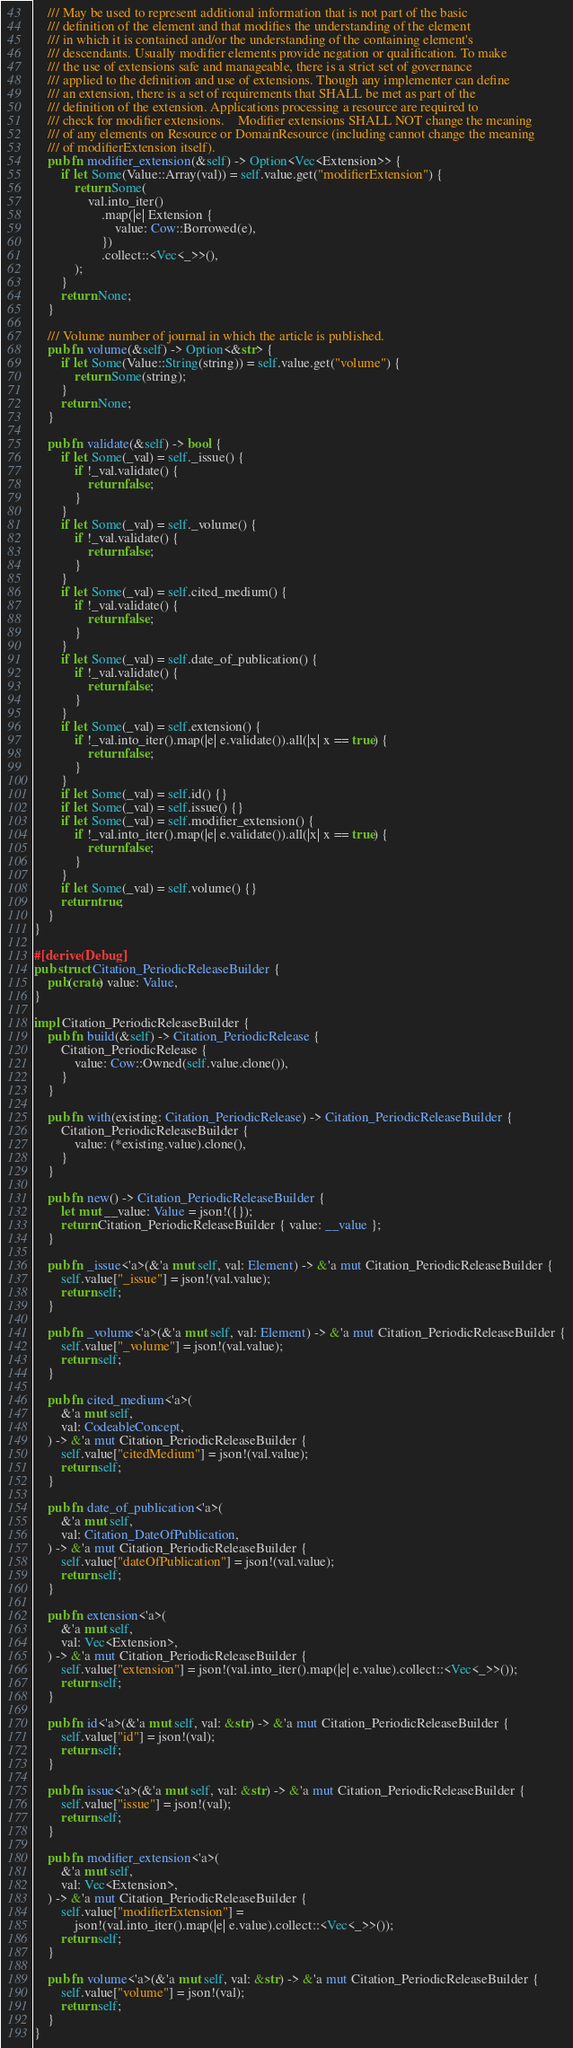Convert code to text. <code><loc_0><loc_0><loc_500><loc_500><_Rust_>
    /// May be used to represent additional information that is not part of the basic
    /// definition of the element and that modifies the understanding of the element
    /// in which it is contained and/or the understanding of the containing element's
    /// descendants. Usually modifier elements provide negation or qualification. To make
    /// the use of extensions safe and manageable, there is a strict set of governance
    /// applied to the definition and use of extensions. Though any implementer can define
    /// an extension, there is a set of requirements that SHALL be met as part of the
    /// definition of the extension. Applications processing a resource are required to
    /// check for modifier extensions.    Modifier extensions SHALL NOT change the meaning
    /// of any elements on Resource or DomainResource (including cannot change the meaning
    /// of modifierExtension itself).
    pub fn modifier_extension(&self) -> Option<Vec<Extension>> {
        if let Some(Value::Array(val)) = self.value.get("modifierExtension") {
            return Some(
                val.into_iter()
                    .map(|e| Extension {
                        value: Cow::Borrowed(e),
                    })
                    .collect::<Vec<_>>(),
            );
        }
        return None;
    }

    /// Volume number of journal in which the article is published.
    pub fn volume(&self) -> Option<&str> {
        if let Some(Value::String(string)) = self.value.get("volume") {
            return Some(string);
        }
        return None;
    }

    pub fn validate(&self) -> bool {
        if let Some(_val) = self._issue() {
            if !_val.validate() {
                return false;
            }
        }
        if let Some(_val) = self._volume() {
            if !_val.validate() {
                return false;
            }
        }
        if let Some(_val) = self.cited_medium() {
            if !_val.validate() {
                return false;
            }
        }
        if let Some(_val) = self.date_of_publication() {
            if !_val.validate() {
                return false;
            }
        }
        if let Some(_val) = self.extension() {
            if !_val.into_iter().map(|e| e.validate()).all(|x| x == true) {
                return false;
            }
        }
        if let Some(_val) = self.id() {}
        if let Some(_val) = self.issue() {}
        if let Some(_val) = self.modifier_extension() {
            if !_val.into_iter().map(|e| e.validate()).all(|x| x == true) {
                return false;
            }
        }
        if let Some(_val) = self.volume() {}
        return true;
    }
}

#[derive(Debug)]
pub struct Citation_PeriodicReleaseBuilder {
    pub(crate) value: Value,
}

impl Citation_PeriodicReleaseBuilder {
    pub fn build(&self) -> Citation_PeriodicRelease {
        Citation_PeriodicRelease {
            value: Cow::Owned(self.value.clone()),
        }
    }

    pub fn with(existing: Citation_PeriodicRelease) -> Citation_PeriodicReleaseBuilder {
        Citation_PeriodicReleaseBuilder {
            value: (*existing.value).clone(),
        }
    }

    pub fn new() -> Citation_PeriodicReleaseBuilder {
        let mut __value: Value = json!({});
        return Citation_PeriodicReleaseBuilder { value: __value };
    }

    pub fn _issue<'a>(&'a mut self, val: Element) -> &'a mut Citation_PeriodicReleaseBuilder {
        self.value["_issue"] = json!(val.value);
        return self;
    }

    pub fn _volume<'a>(&'a mut self, val: Element) -> &'a mut Citation_PeriodicReleaseBuilder {
        self.value["_volume"] = json!(val.value);
        return self;
    }

    pub fn cited_medium<'a>(
        &'a mut self,
        val: CodeableConcept,
    ) -> &'a mut Citation_PeriodicReleaseBuilder {
        self.value["citedMedium"] = json!(val.value);
        return self;
    }

    pub fn date_of_publication<'a>(
        &'a mut self,
        val: Citation_DateOfPublication,
    ) -> &'a mut Citation_PeriodicReleaseBuilder {
        self.value["dateOfPublication"] = json!(val.value);
        return self;
    }

    pub fn extension<'a>(
        &'a mut self,
        val: Vec<Extension>,
    ) -> &'a mut Citation_PeriodicReleaseBuilder {
        self.value["extension"] = json!(val.into_iter().map(|e| e.value).collect::<Vec<_>>());
        return self;
    }

    pub fn id<'a>(&'a mut self, val: &str) -> &'a mut Citation_PeriodicReleaseBuilder {
        self.value["id"] = json!(val);
        return self;
    }

    pub fn issue<'a>(&'a mut self, val: &str) -> &'a mut Citation_PeriodicReleaseBuilder {
        self.value["issue"] = json!(val);
        return self;
    }

    pub fn modifier_extension<'a>(
        &'a mut self,
        val: Vec<Extension>,
    ) -> &'a mut Citation_PeriodicReleaseBuilder {
        self.value["modifierExtension"] =
            json!(val.into_iter().map(|e| e.value).collect::<Vec<_>>());
        return self;
    }

    pub fn volume<'a>(&'a mut self, val: &str) -> &'a mut Citation_PeriodicReleaseBuilder {
        self.value["volume"] = json!(val);
        return self;
    }
}
</code> 